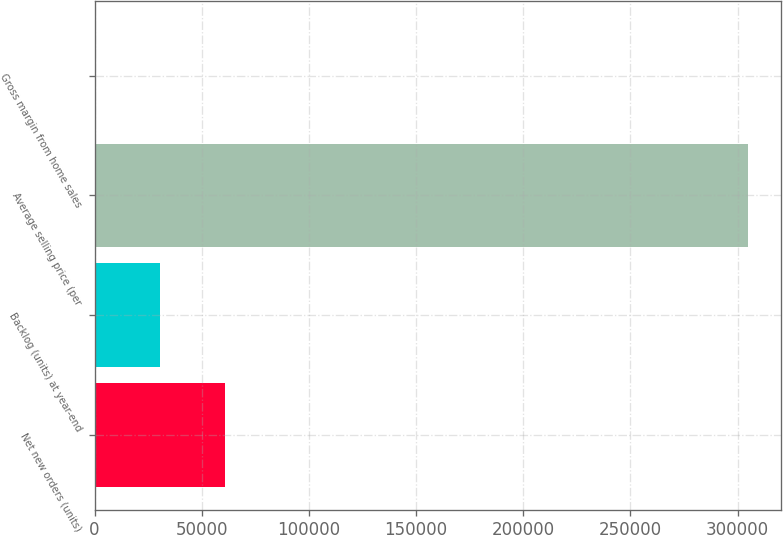Convert chart to OTSL. <chart><loc_0><loc_0><loc_500><loc_500><bar_chart><fcel>Net new orders (units)<fcel>Backlog (units) at year-end<fcel>Average selling price (per<fcel>Gross margin from home sales<nl><fcel>61016.4<fcel>30518.5<fcel>305000<fcel>20.5<nl></chart> 